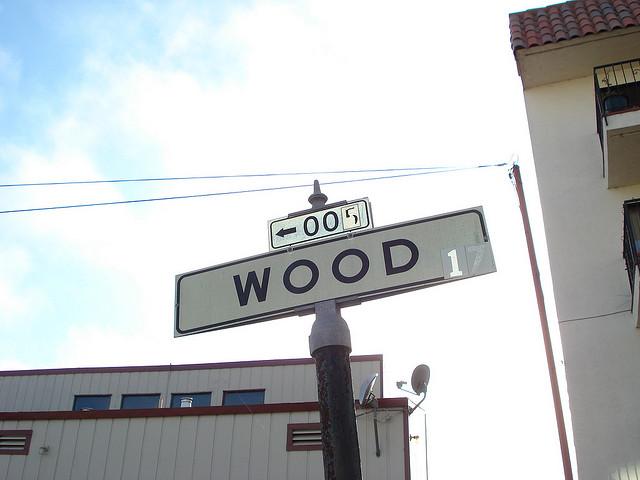Is this an old street sign?
Write a very short answer. Yes. What color are the signs?
Concise answer only. White. Is the street named after a scientist?
Write a very short answer. No. Is the name of the street "Wood"?
Be succinct. Yes. What color is the sign?
Answer briefly. White. If one goes left, what kind of point of interest would one find?
Quick response, please. Wood. Where is a TV satellite?
Short answer required. Building. What does the W stand for?
Give a very brief answer. Wood. What does the arrow represent?
Quick response, please. Left. What are all the numbers in these picture starting left and going to the right?
Answer briefly. 005. What is above the stop sign?
Be succinct. 005. Is this a two way street?
Be succinct. No. What does the street sign say?
Quick response, please. Wood. Has the sign been graffitied?
Keep it brief. No. What is the first letter of the top sign?
Quick response, please. W. What street is being displayed?
Answer briefly. Wood. 